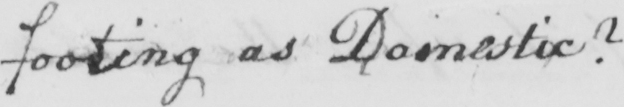What does this handwritten line say? footing as Domestic ? 